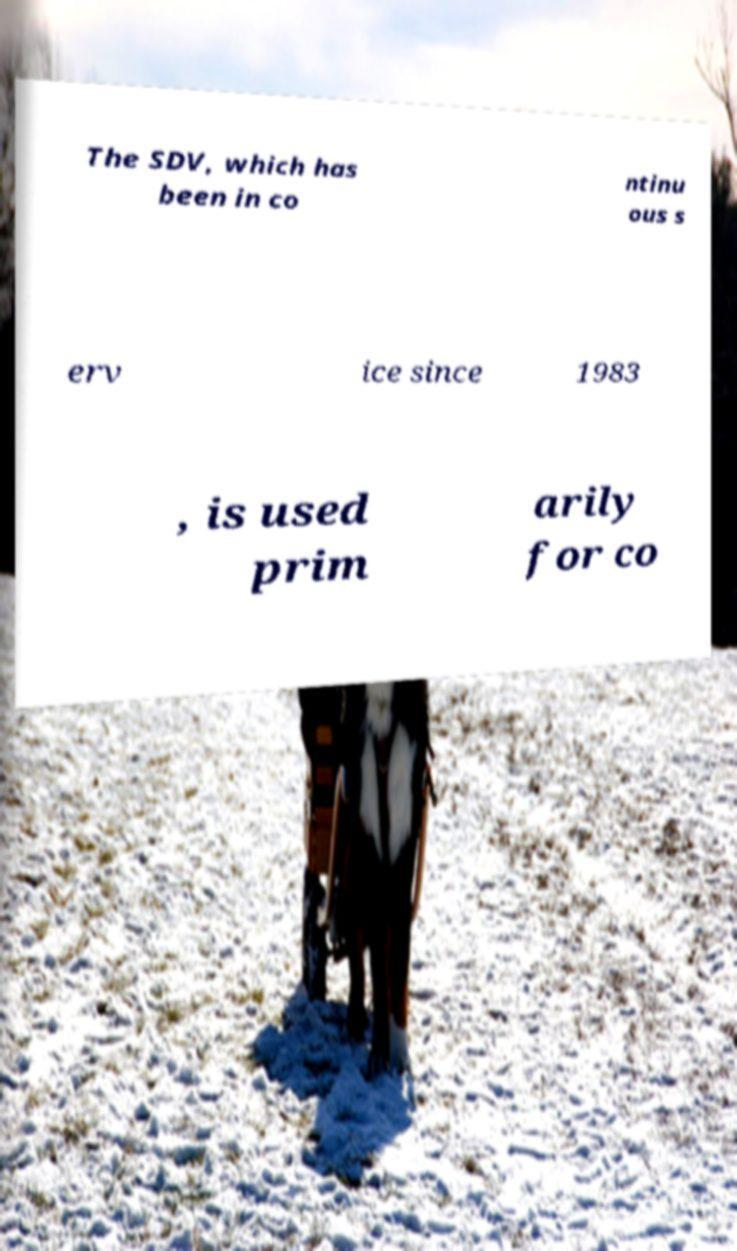Please read and relay the text visible in this image. What does it say? The SDV, which has been in co ntinu ous s erv ice since 1983 , is used prim arily for co 